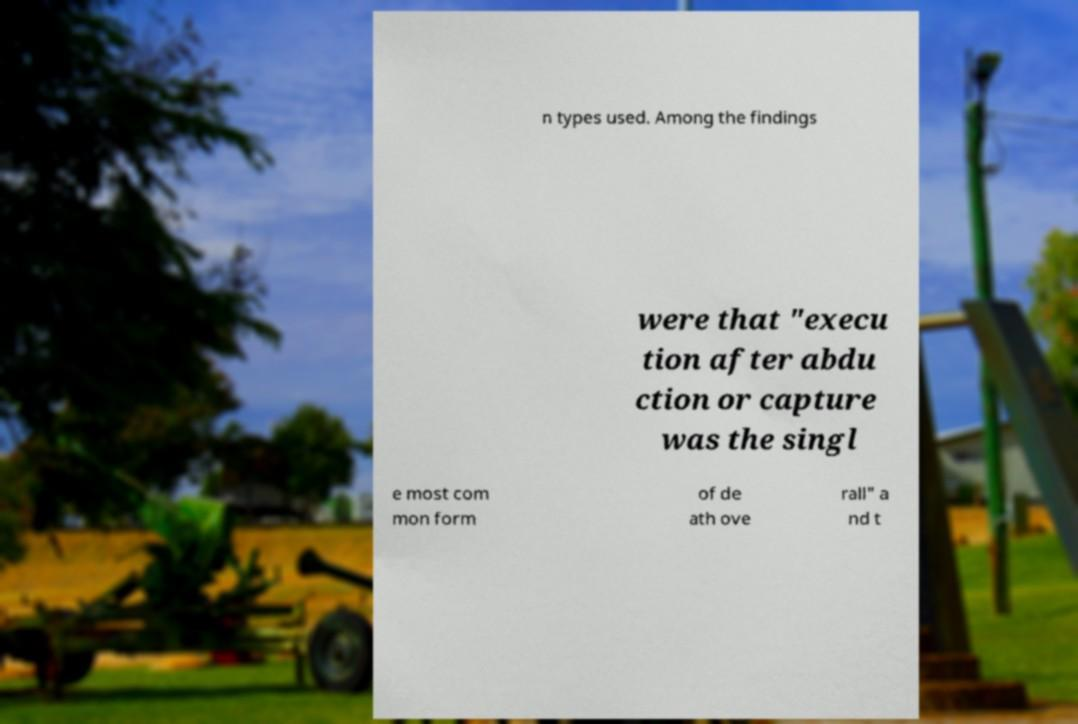Please identify and transcribe the text found in this image. n types used. Among the findings were that "execu tion after abdu ction or capture was the singl e most com mon form of de ath ove rall" a nd t 